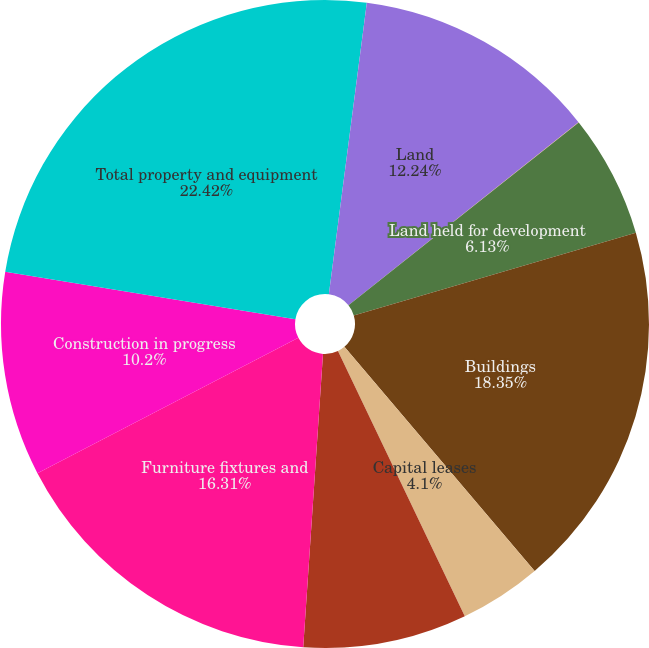Convert chart. <chart><loc_0><loc_0><loc_500><loc_500><pie_chart><fcel>(In thousands)<fcel>Land<fcel>Land held for sale<fcel>Land held for development<fcel>Buildings<fcel>Capital leases<fcel>Leasehold improvements<fcel>Furniture fixtures and<fcel>Construction in progress<fcel>Total property and equipment<nl><fcel>2.06%<fcel>12.24%<fcel>0.02%<fcel>6.13%<fcel>18.35%<fcel>4.1%<fcel>8.17%<fcel>16.31%<fcel>10.2%<fcel>22.42%<nl></chart> 